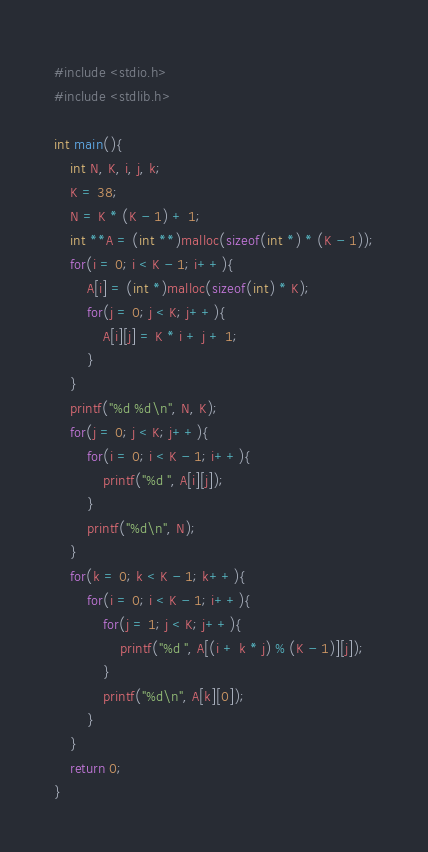Convert code to text. <code><loc_0><loc_0><loc_500><loc_500><_C_>#include <stdio.h>
#include <stdlib.h>

int main(){
	int N, K, i, j, k;
	K = 38;
	N = K * (K - 1) + 1;
	int **A = (int **)malloc(sizeof(int *) * (K - 1));
	for(i = 0; i < K - 1; i++){
		A[i] = (int *)malloc(sizeof(int) * K);
		for(j = 0; j < K; j++){
			A[i][j] = K * i + j + 1;
		}
	}
	printf("%d %d\n", N, K);
	for(j = 0; j < K; j++){
		for(i = 0; i < K - 1; i++){
			printf("%d ", A[i][j]);
		}
		printf("%d\n", N);
	}
	for(k = 0; k < K - 1; k++){
		for(i = 0; i < K - 1; i++){
			for(j = 1; j < K; j++){
				printf("%d ", A[(i + k * j) % (K - 1)][j]);
			}
			printf("%d\n", A[k][0]);
		}
	}
	return 0;
}</code> 